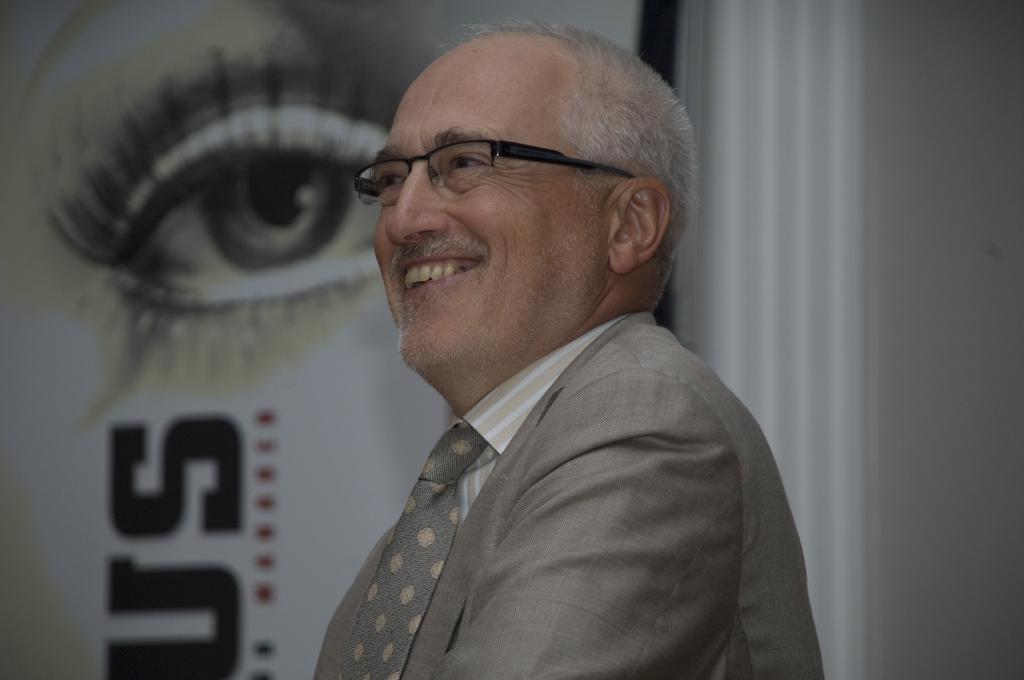Please provide a concise description of this image. In this image we can see a man. On the backside we can see the picture of an eye and some text on a wall. 